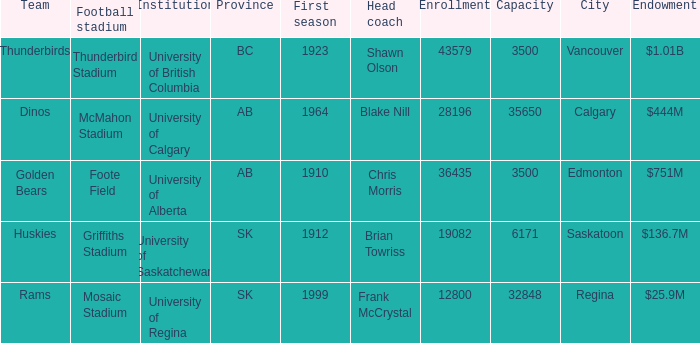Help me parse the entirety of this table. {'header': ['Team', 'Football stadium', 'Institution', 'Province', 'First season', 'Head coach', 'Enrollment', 'Capacity', 'City', 'Endowment'], 'rows': [['Thunderbirds', 'Thunderbird Stadium', 'University of British Columbia', 'BC', '1923', 'Shawn Olson', '43579', '3500', 'Vancouver', '$1.01B'], ['Dinos', 'McMahon Stadium', 'University of Calgary', 'AB', '1964', 'Blake Nill', '28196', '35650', 'Calgary', '$444M'], ['Golden Bears', 'Foote Field', 'University of Alberta', 'AB', '1910', 'Chris Morris', '36435', '3500', 'Edmonton', '$751M'], ['Huskies', 'Griffiths Stadium', 'University of Saskatchewan', 'SK', '1912', 'Brian Towriss', '19082', '6171', 'Saskatoon', '$136.7M'], ['Rams', 'Mosaic Stadium', 'University of Regina', 'SK', '1999', 'Frank McCrystal', '12800', '32848', 'Regina', '$25.9M']]} How many endowments does Mosaic Stadium have? 1.0. 